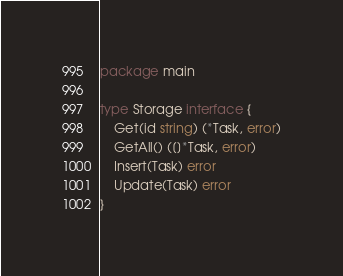Convert code to text. <code><loc_0><loc_0><loc_500><loc_500><_Go_>package main

type Storage interface {
	Get(id string) (*Task, error)
	GetAll() ([]*Task, error)
	Insert(Task) error
	Update(Task) error
}
</code> 